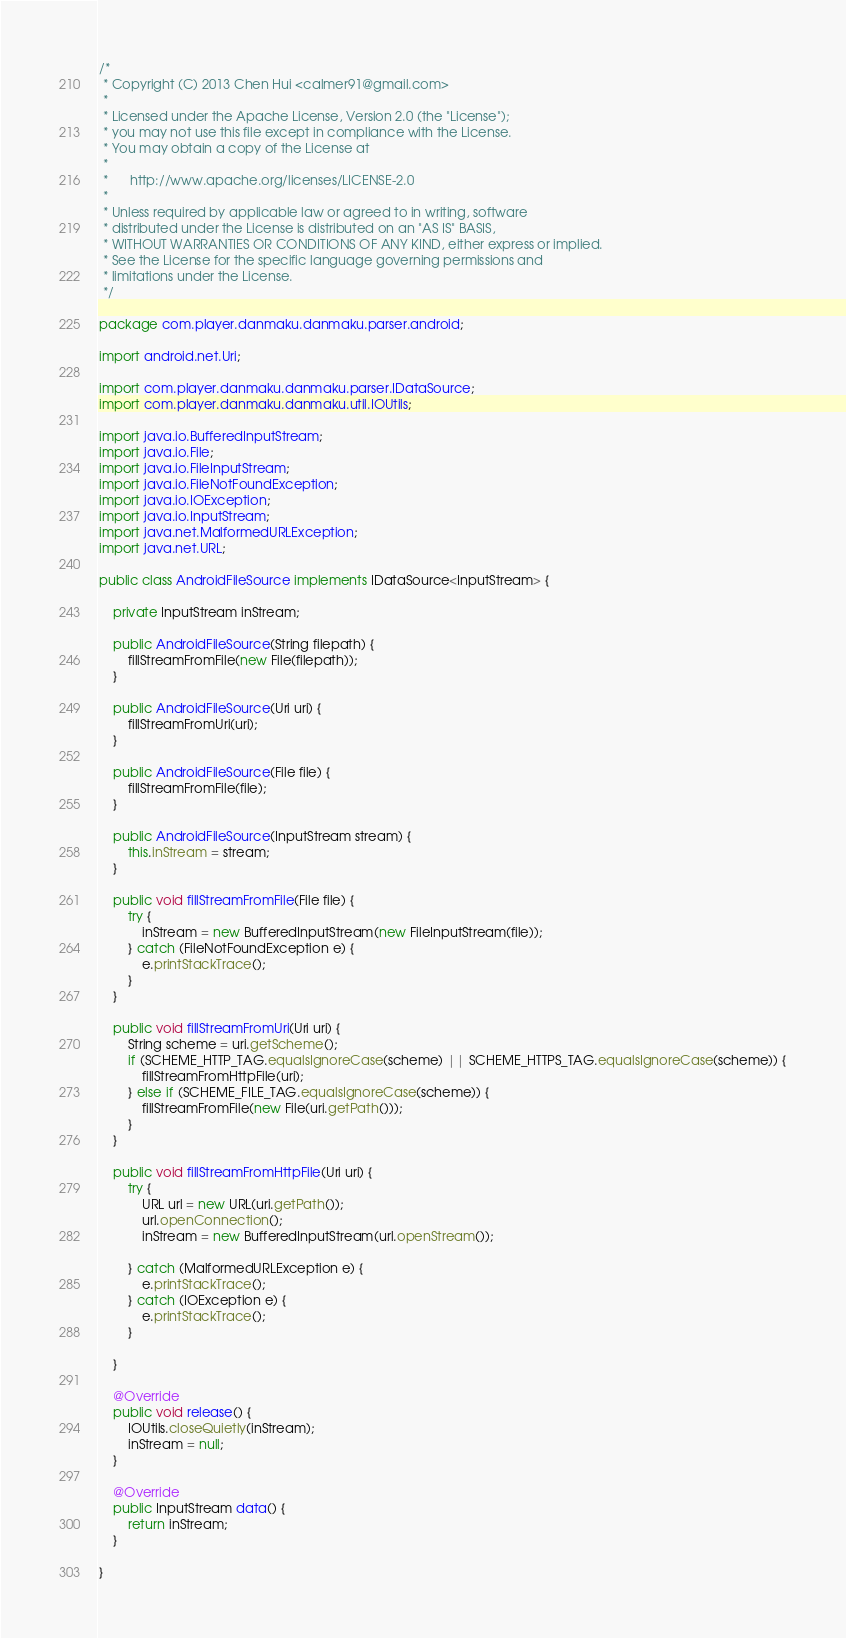Convert code to text. <code><loc_0><loc_0><loc_500><loc_500><_Java_>/*
 * Copyright (C) 2013 Chen Hui <calmer91@gmail.com>
 *
 * Licensed under the Apache License, Version 2.0 (the "License");
 * you may not use this file except in compliance with the License.
 * You may obtain a copy of the License at
 *
 *      http://www.apache.org/licenses/LICENSE-2.0
 *
 * Unless required by applicable law or agreed to in writing, software
 * distributed under the License is distributed on an "AS IS" BASIS,
 * WITHOUT WARRANTIES OR CONDITIONS OF ANY KIND, either express or implied.
 * See the License for the specific language governing permissions and
 * limitations under the License.
 */

package com.player.danmaku.danmaku.parser.android;

import android.net.Uri;

import com.player.danmaku.danmaku.parser.IDataSource;
import com.player.danmaku.danmaku.util.IOUtils;

import java.io.BufferedInputStream;
import java.io.File;
import java.io.FileInputStream;
import java.io.FileNotFoundException;
import java.io.IOException;
import java.io.InputStream;
import java.net.MalformedURLException;
import java.net.URL;

public class AndroidFileSource implements IDataSource<InputStream> {

    private InputStream inStream;

    public AndroidFileSource(String filepath) {
        fillStreamFromFile(new File(filepath));
    }

    public AndroidFileSource(Uri uri) {
        fillStreamFromUri(uri);
    }

    public AndroidFileSource(File file) {
        fillStreamFromFile(file);
    }

    public AndroidFileSource(InputStream stream) {
        this.inStream = stream;
    }

    public void fillStreamFromFile(File file) {
        try {
            inStream = new BufferedInputStream(new FileInputStream(file));
        } catch (FileNotFoundException e) {
            e.printStackTrace();
        }
    }

    public void fillStreamFromUri(Uri uri) {
        String scheme = uri.getScheme();
        if (SCHEME_HTTP_TAG.equalsIgnoreCase(scheme) || SCHEME_HTTPS_TAG.equalsIgnoreCase(scheme)) {
            fillStreamFromHttpFile(uri);
        } else if (SCHEME_FILE_TAG.equalsIgnoreCase(scheme)) {
            fillStreamFromFile(new File(uri.getPath()));
        }
    }

    public void fillStreamFromHttpFile(Uri uri) {
        try {
            URL url = new URL(uri.getPath());
            url.openConnection();
            inStream = new BufferedInputStream(url.openStream());

        } catch (MalformedURLException e) {
            e.printStackTrace();
        } catch (IOException e) {
            e.printStackTrace();
        }

    }

    @Override
    public void release() {
        IOUtils.closeQuietly(inStream);
        inStream = null;
    }

	@Override
	public InputStream data() {
		return inStream;
	}

}
</code> 